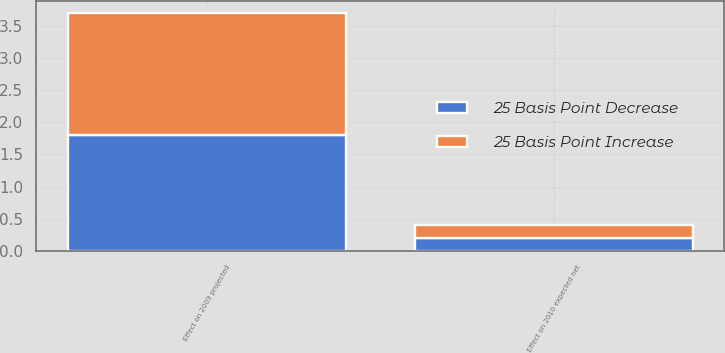Convert chart to OTSL. <chart><loc_0><loc_0><loc_500><loc_500><stacked_bar_chart><ecel><fcel>Effect on 2009 projected<fcel>Effect on 2010 expected net<nl><fcel>25 Basis Point Decrease<fcel>1.8<fcel>0.2<nl><fcel>25 Basis Point Increase<fcel>1.9<fcel>0.2<nl></chart> 